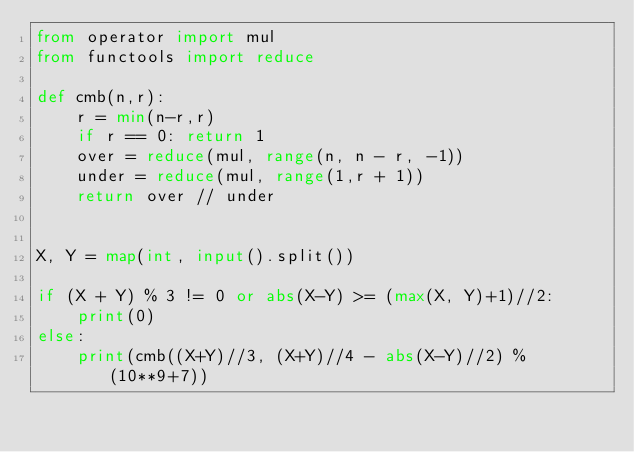<code> <loc_0><loc_0><loc_500><loc_500><_Python_>from operator import mul
from functools import reduce

def cmb(n,r):
    r = min(n-r,r)
    if r == 0: return 1
    over = reduce(mul, range(n, n - r, -1))
    under = reduce(mul, range(1,r + 1))
    return over // under


X, Y = map(int, input().split())

if (X + Y) % 3 != 0 or abs(X-Y) >= (max(X, Y)+1)//2:
    print(0)
else:
    print(cmb((X+Y)//3, (X+Y)//4 - abs(X-Y)//2) % (10**9+7))</code> 